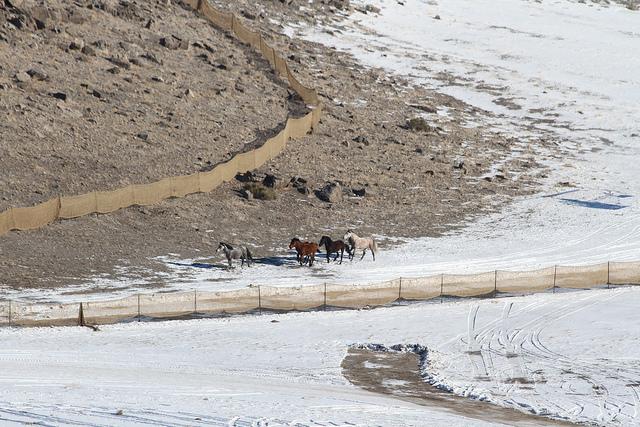Are the horses all the same color?
Give a very brief answer. No. What type of fence is in the picture?
Keep it brief. Fabric. What is on the ground?
Keep it brief. Snow. 